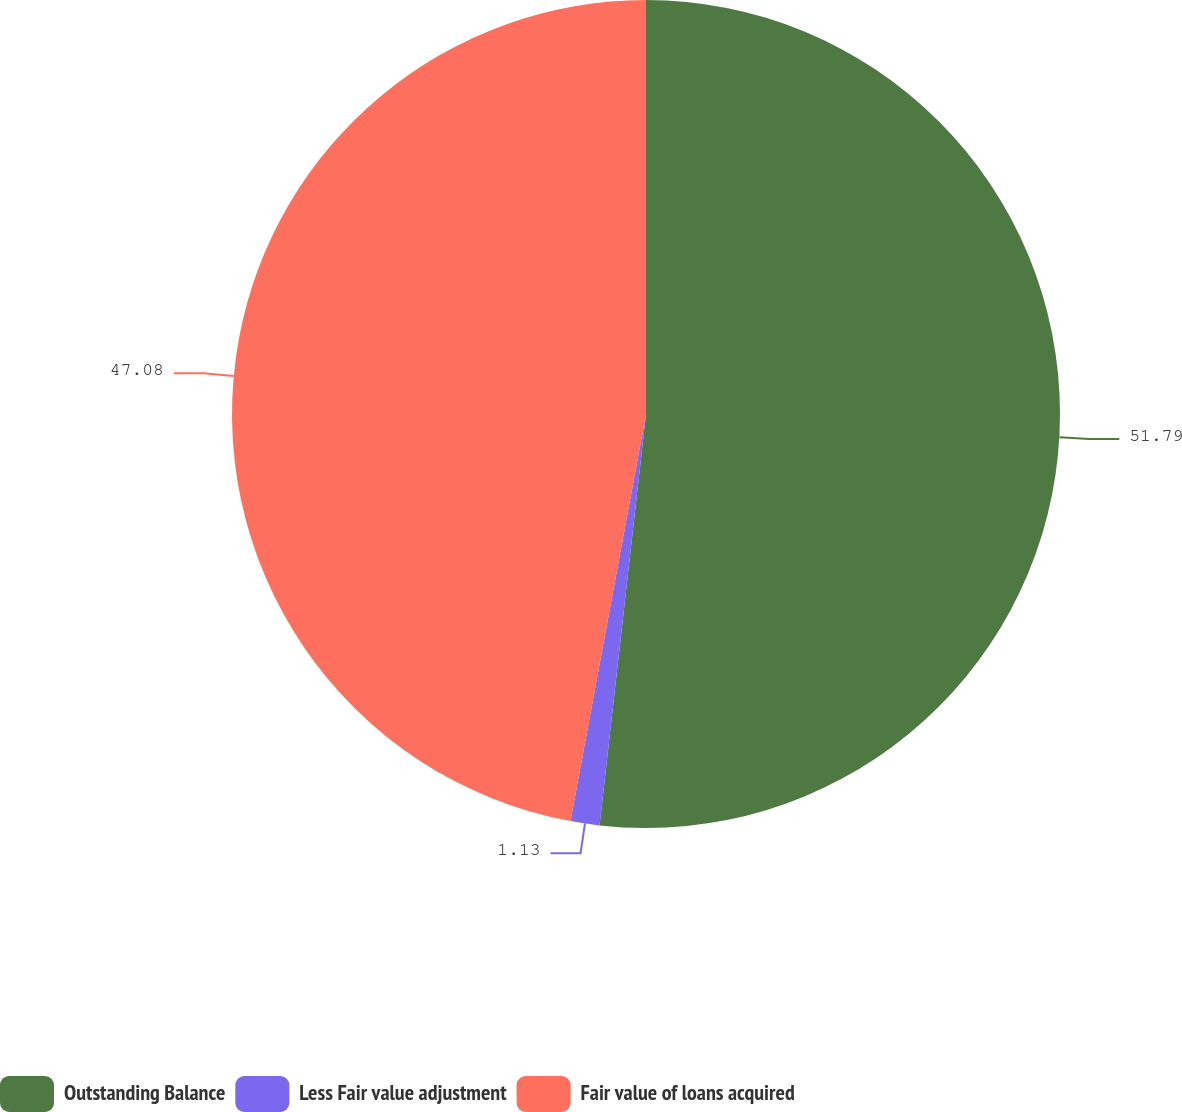Convert chart. <chart><loc_0><loc_0><loc_500><loc_500><pie_chart><fcel>Outstanding Balance<fcel>Less Fair value adjustment<fcel>Fair value of loans acquired<nl><fcel>51.79%<fcel>1.13%<fcel>47.08%<nl></chart> 